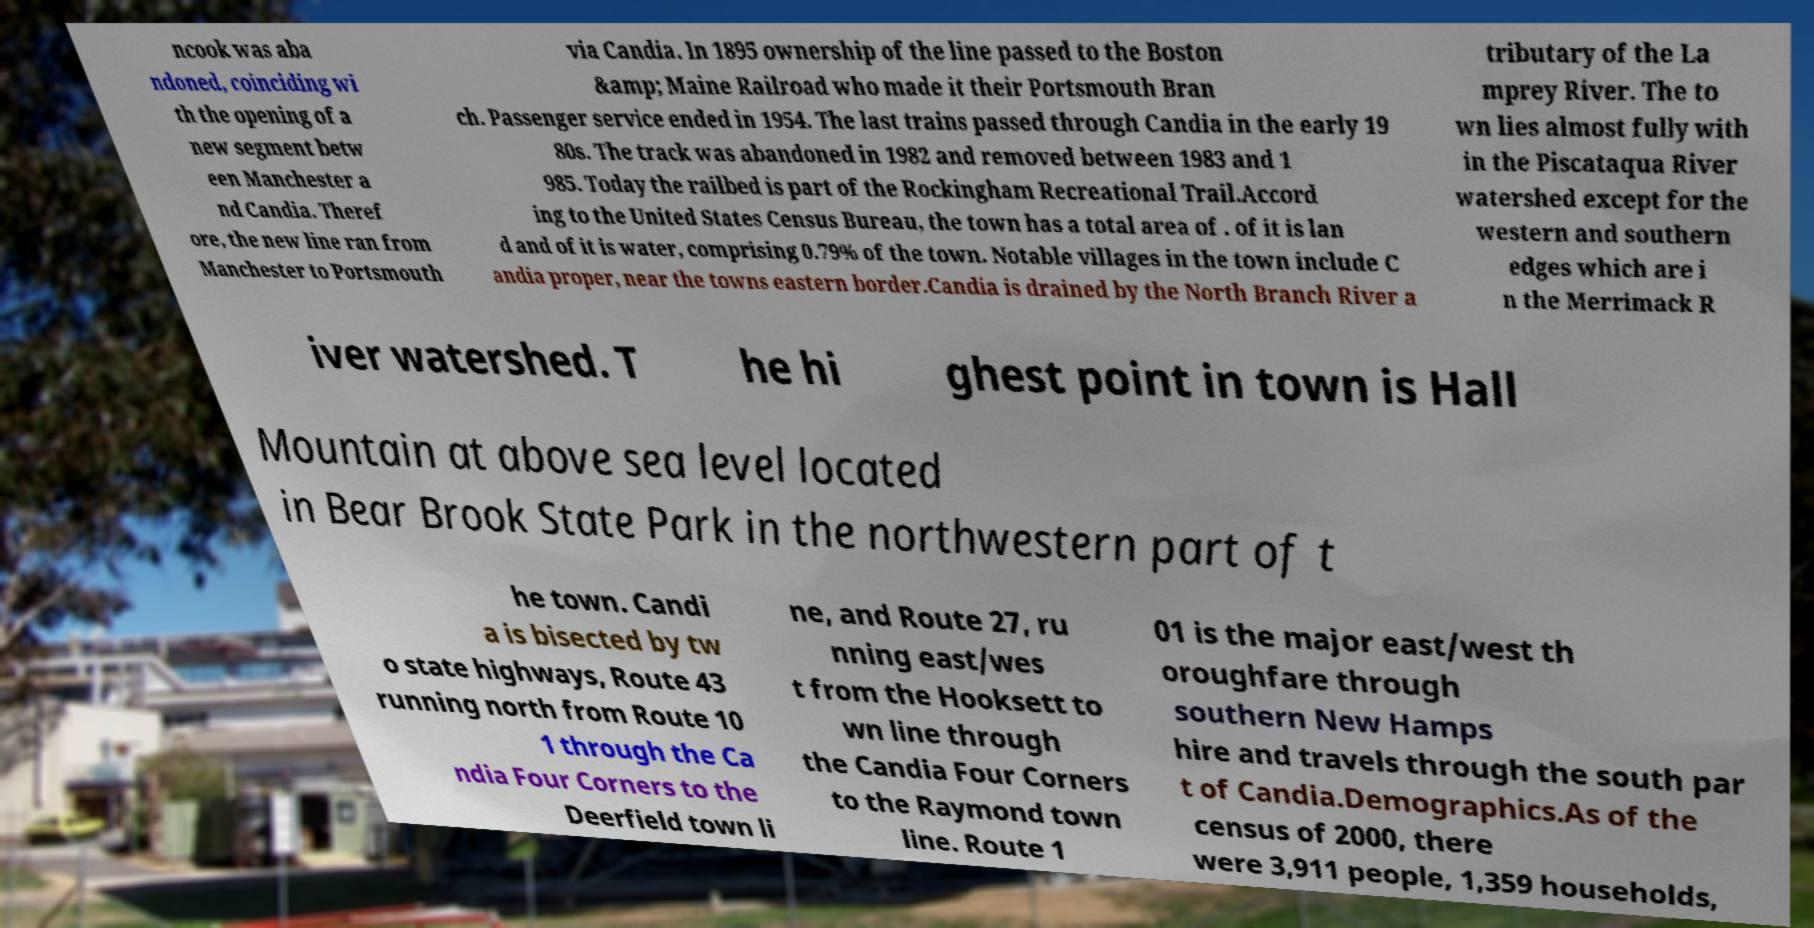Can you accurately transcribe the text from the provided image for me? ncook was aba ndoned, coinciding wi th the opening of a new segment betw een Manchester a nd Candia. Theref ore, the new line ran from Manchester to Portsmouth via Candia. In 1895 ownership of the line passed to the Boston &amp; Maine Railroad who made it their Portsmouth Bran ch. Passenger service ended in 1954. The last trains passed through Candia in the early 19 80s. The track was abandoned in 1982 and removed between 1983 and 1 985. Today the railbed is part of the Rockingham Recreational Trail.Accord ing to the United States Census Bureau, the town has a total area of . of it is lan d and of it is water, comprising 0.79% of the town. Notable villages in the town include C andia proper, near the towns eastern border.Candia is drained by the North Branch River a tributary of the La mprey River. The to wn lies almost fully with in the Piscataqua River watershed except for the western and southern edges which are i n the Merrimack R iver watershed. T he hi ghest point in town is Hall Mountain at above sea level located in Bear Brook State Park in the northwestern part of t he town. Candi a is bisected by tw o state highways, Route 43 running north from Route 10 1 through the Ca ndia Four Corners to the Deerfield town li ne, and Route 27, ru nning east/wes t from the Hooksett to wn line through the Candia Four Corners to the Raymond town line. Route 1 01 is the major east/west th oroughfare through southern New Hamps hire and travels through the south par t of Candia.Demographics.As of the census of 2000, there were 3,911 people, 1,359 households, 